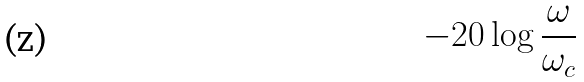Convert formula to latex. <formula><loc_0><loc_0><loc_500><loc_500>- 2 0 \log { \frac { \omega } { \omega _ { c } } }</formula> 